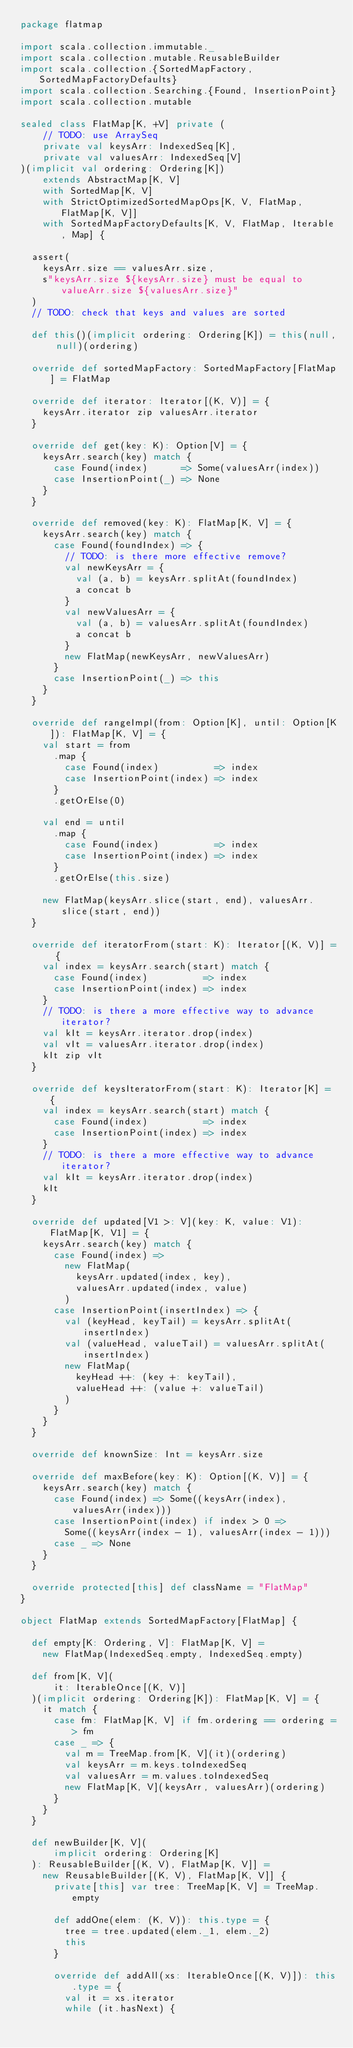Convert code to text. <code><loc_0><loc_0><loc_500><loc_500><_Scala_>package flatmap

import scala.collection.immutable._
import scala.collection.mutable.ReusableBuilder
import scala.collection.{SortedMapFactory, SortedMapFactoryDefaults}
import scala.collection.Searching.{Found, InsertionPoint}
import scala.collection.mutable

sealed class FlatMap[K, +V] private (
    // TODO: use ArraySeq
    private val keysArr: IndexedSeq[K],
    private val valuesArr: IndexedSeq[V]
)(implicit val ordering: Ordering[K])
    extends AbstractMap[K, V]
    with SortedMap[K, V]
    with StrictOptimizedSortedMapOps[K, V, FlatMap, FlatMap[K, V]]
    with SortedMapFactoryDefaults[K, V, FlatMap, Iterable, Map] {

  assert(
    keysArr.size == valuesArr.size,
    s"keysArr.size ${keysArr.size} must be equal to valueArr.size ${valuesArr.size}"
  )
  // TODO: check that keys and values are sorted

  def this()(implicit ordering: Ordering[K]) = this(null, null)(ordering)

  override def sortedMapFactory: SortedMapFactory[FlatMap] = FlatMap

  override def iterator: Iterator[(K, V)] = {
    keysArr.iterator zip valuesArr.iterator
  }

  override def get(key: K): Option[V] = {
    keysArr.search(key) match {
      case Found(index)      => Some(valuesArr(index))
      case InsertionPoint(_) => None
    }
  }

  override def removed(key: K): FlatMap[K, V] = {
    keysArr.search(key) match {
      case Found(foundIndex) => {
        // TODO: is there more effective remove?
        val newKeysArr = {
          val (a, b) = keysArr.splitAt(foundIndex)
          a concat b
        }
        val newValuesArr = {
          val (a, b) = valuesArr.splitAt(foundIndex)
          a concat b
        }
        new FlatMap(newKeysArr, newValuesArr)
      }
      case InsertionPoint(_) => this
    }
  }

  override def rangeImpl(from: Option[K], until: Option[K]): FlatMap[K, V] = {
    val start = from
      .map {
        case Found(index)          => index
        case InsertionPoint(index) => index
      }
      .getOrElse(0)

    val end = until
      .map {
        case Found(index)          => index
        case InsertionPoint(index) => index
      }
      .getOrElse(this.size)

    new FlatMap(keysArr.slice(start, end), valuesArr.slice(start, end))
  }

  override def iteratorFrom(start: K): Iterator[(K, V)] = {
    val index = keysArr.search(start) match {
      case Found(index)          => index
      case InsertionPoint(index) => index
    }
    // TODO: is there a more effective way to advance iterator?
    val kIt = keysArr.iterator.drop(index)
    val vIt = valuesArr.iterator.drop(index)
    kIt zip vIt
  }

  override def keysIteratorFrom(start: K): Iterator[K] = {
    val index = keysArr.search(start) match {
      case Found(index)          => index
      case InsertionPoint(index) => index
    }
    // TODO: is there a more effective way to advance iterator?
    val kIt = keysArr.iterator.drop(index)
    kIt
  }

  override def updated[V1 >: V](key: K, value: V1): FlatMap[K, V1] = {
    keysArr.search(key) match {
      case Found(index) =>
        new FlatMap(
          keysArr.updated(index, key),
          valuesArr.updated(index, value)
        )
      case InsertionPoint(insertIndex) => {
        val (keyHead, keyTail) = keysArr.splitAt(insertIndex)
        val (valueHead, valueTail) = valuesArr.splitAt(insertIndex)
        new FlatMap(
          keyHead ++: (key +: keyTail),
          valueHead ++: (value +: valueTail)
        )
      }
    }
  }

  override def knownSize: Int = keysArr.size

  override def maxBefore(key: K): Option[(K, V)] = {
    keysArr.search(key) match {
      case Found(index) => Some((keysArr(index), valuesArr(index)))
      case InsertionPoint(index) if index > 0 =>
        Some((keysArr(index - 1), valuesArr(index - 1)))
      case _ => None
    }
  }

  override protected[this] def className = "FlatMap"
}

object FlatMap extends SortedMapFactory[FlatMap] {

  def empty[K: Ordering, V]: FlatMap[K, V] =
    new FlatMap(IndexedSeq.empty, IndexedSeq.empty)

  def from[K, V](
      it: IterableOnce[(K, V)]
  )(implicit ordering: Ordering[K]): FlatMap[K, V] = {
    it match {
      case fm: FlatMap[K, V] if fm.ordering == ordering => fm
      case _ => {
        val m = TreeMap.from[K, V](it)(ordering)
        val keysArr = m.keys.toIndexedSeq
        val valuesArr = m.values.toIndexedSeq
        new FlatMap[K, V](keysArr, valuesArr)(ordering)
      }
    }
  }

  def newBuilder[K, V](
      implicit ordering: Ordering[K]
  ): ReusableBuilder[(K, V), FlatMap[K, V]] =
    new ReusableBuilder[(K, V), FlatMap[K, V]] {
      private[this] var tree: TreeMap[K, V] = TreeMap.empty

      def addOne(elem: (K, V)): this.type = {
        tree = tree.updated(elem._1, elem._2)
        this
      }

      override def addAll(xs: IterableOnce[(K, V)]): this.type = {
        val it = xs.iterator
        while (it.hasNext) {</code> 